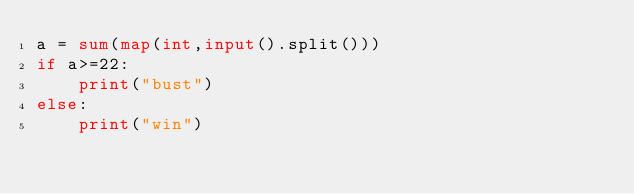<code> <loc_0><loc_0><loc_500><loc_500><_Python_>a = sum(map(int,input().split()))
if a>=22:
    print("bust")
else:
    print("win")</code> 